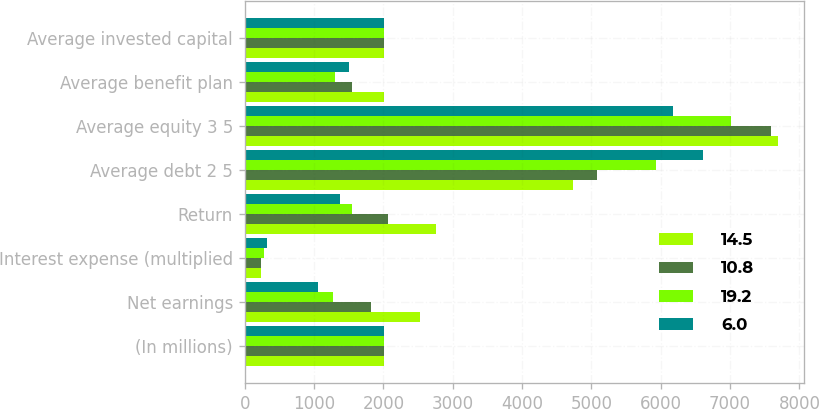<chart> <loc_0><loc_0><loc_500><loc_500><stacked_bar_chart><ecel><fcel>(In millions)<fcel>Net earnings<fcel>Interest expense (multiplied<fcel>Return<fcel>Average debt 2 5<fcel>Average equity 3 5<fcel>Average benefit plan<fcel>Average invested capital<nl><fcel>14.5<fcel>2006<fcel>2529<fcel>235<fcel>2764<fcel>4727<fcel>7686<fcel>2006<fcel>2004.5<nl><fcel>10.8<fcel>2005<fcel>1825<fcel>241<fcel>2066<fcel>5077<fcel>7590<fcel>1545<fcel>2004.5<nl><fcel>19.2<fcel>2004<fcel>1266<fcel>276<fcel>1542<fcel>5932<fcel>7015<fcel>1296<fcel>2004.5<nl><fcel>6<fcel>2003<fcel>1053<fcel>317<fcel>1370<fcel>6612<fcel>6170<fcel>1504<fcel>2004.5<nl></chart> 